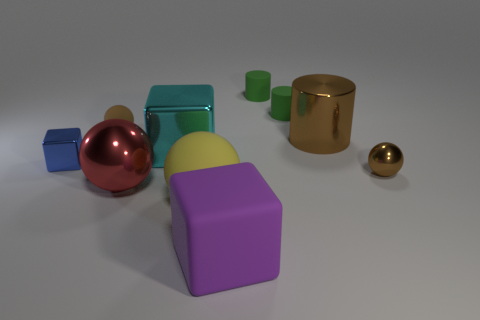There is a shiny ball that is the same color as the large cylinder; what is its size?
Provide a short and direct response. Small. There is a big thing that is the same color as the small matte sphere; what shape is it?
Offer a very short reply. Cylinder. There is a brown sphere that is to the right of the cube that is in front of the tiny blue cube on the left side of the large red object; what size is it?
Give a very brief answer. Small. What is the tiny blue thing made of?
Provide a short and direct response. Metal. Does the tiny blue thing have the same material as the tiny brown sphere on the right side of the big brown metallic cylinder?
Your answer should be compact. Yes. Is there anything else that has the same color as the big cylinder?
Offer a terse response. Yes. There is a shiny sphere in front of the brown metallic object in front of the big cyan cube; is there a brown cylinder that is right of it?
Ensure brevity in your answer.  Yes. The tiny metallic ball is what color?
Offer a very short reply. Brown. Are there any small brown objects to the right of the small shiny sphere?
Your answer should be very brief. No. There is a large purple matte object; is its shape the same as the tiny metal thing on the left side of the large brown metallic object?
Offer a terse response. Yes. 